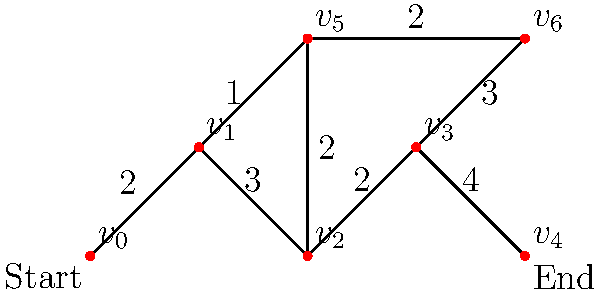As a video game developer, you're designing a maze-like level where players need to find the shortest path from start to finish. The maze can be represented as a weighted graph, where vertices are decision points and edges are paths with associated distances. Given the graph above, what is the length of the shortest path from $v_0$ (Start) to $v_4$ (End)? To find the shortest path, we can use Dijkstra's algorithm, which is commonly used in pathfinding for video games. Let's apply it step-by-step:

1) Initialize distances: $d(v_0) = 0$, all others $\infty$
2) Set $S = \{\}$, $Q = \{v_0, v_1, v_2, v_3, v_4, v_5, v_6\}$

3) While $Q$ is not empty:
   a) Select vertex $u$ in $Q$ with minimum $d(u)$
   b) Remove $u$ from $Q$ and add to $S$
   c) For each neighbor $v$ of $u$:
      If $d(v) > d(u) + w(u,v)$, update $d(v) = d(u) + w(u,v)$

4) Iterations:
   - Select $v_0$: Update $d(v_1) = 2$
   - Select $v_1$: Update $d(v_2) = 5$, $d(v_5) = 3$
   - Select $v_5$: Update $d(v_6) = 5$, $d(v_2) = \min(5, 3+2) = 5$
   - Select $v_2$: Update $d(v_3) = 7$
   - Select $v_6$: Update $d(v_3) = \min(7, 5+3) = 8$
   - Select $v_3$: Update $d(v_4) = 12$
   - Select $v_4$: Done

5) The shortest path length from $v_0$ to $v_4$ is $d(v_4) = 12$

This algorithm mimics how a player might explore the maze, always choosing the shortest known path and updating their knowledge as they discover new routes.
Answer: 12 